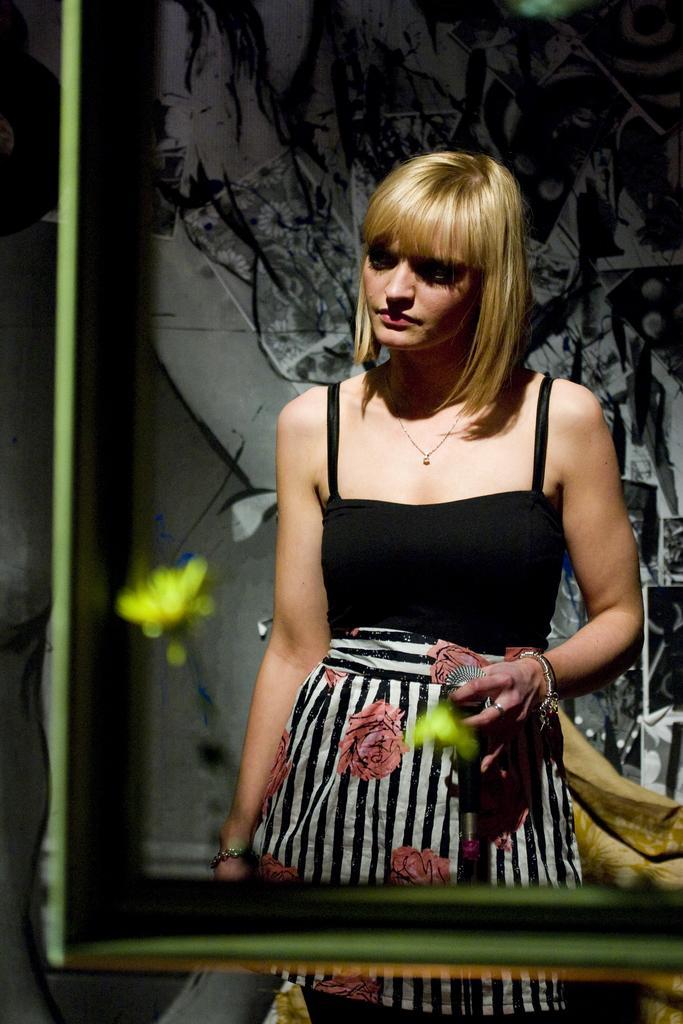Please provide a concise description of this image. In the center of the picture there is a woman standing, she is a holding a glass and she is wearing a black dress. In the foreground it is not clear. In the background it is well with some designs on it. 